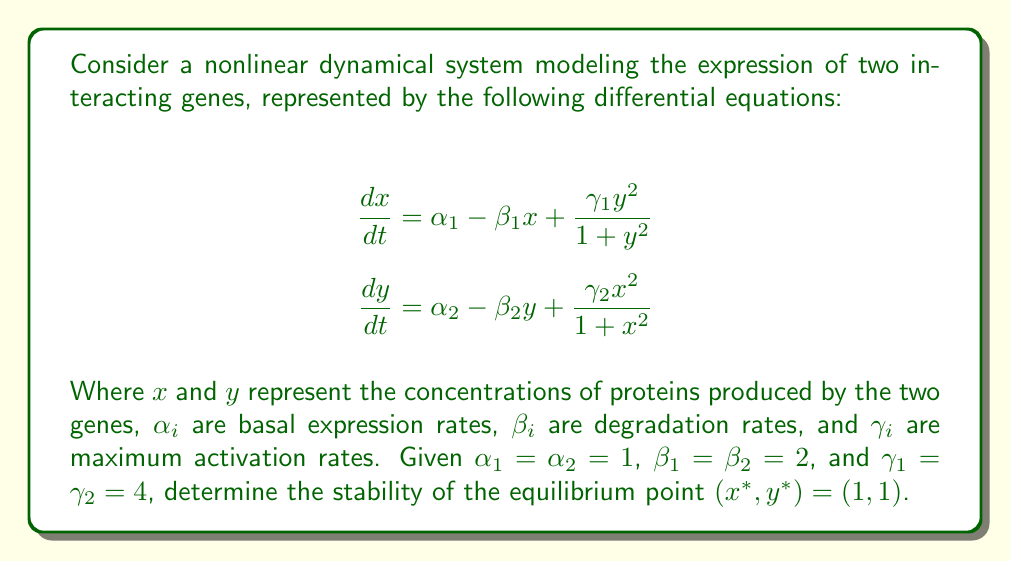What is the answer to this math problem? To analyze the stability of the equilibrium point, we need to follow these steps:

1) Calculate the Jacobian matrix of the system at the equilibrium point.
2) Find the eigenvalues of the Jacobian matrix.
3) Determine the stability based on the signs of the real parts of the eigenvalues.

Step 1: Calculate the Jacobian matrix

The Jacobian matrix is given by:

$$J = \begin{bmatrix}
\frac{\partial f_1}{\partial x} & \frac{\partial f_1}{\partial y} \\
\frac{\partial f_2}{\partial x} & \frac{\partial f_2}{\partial y}
\end{bmatrix}$$

Where:
$$\begin{align}
f_1 &= \alpha_1 - \beta_1 x + \frac{\gamma_1 y^2}{1 + y^2} \\
f_2 &= \alpha_2 - \beta_2 y + \frac{\gamma_2 x^2}{1 + x^2}
\end{align}$$

Calculating the partial derivatives:

$$\begin{align}
\frac{\partial f_1}{\partial x} &= -\beta_1 = -2 \\
\frac{\partial f_1}{\partial y} &= \frac{2\gamma_1 y}{(1 + y^2)^2} = \frac{8}{4} = 2 \quad \text{(at } y = 1\text{)} \\
\frac{\partial f_2}{\partial x} &= \frac{2\gamma_2 x}{(1 + x^2)^2} = \frac{8}{4} = 2 \quad \text{(at } x = 1\text{)} \\
\frac{\partial f_2}{\partial y} &= -\beta_2 = -2
\end{align}$$

Therefore, the Jacobian matrix at $(1, 1)$ is:

$$J = \begin{bmatrix}
-2 & 2 \\
2 & -2
\end{bmatrix}$$

Step 2: Find the eigenvalues

The characteristic equation is:
$$\det(J - \lambda I) = \begin{vmatrix}
-2 - \lambda & 2 \\
2 & -2 - \lambda
\end{vmatrix} = \lambda^2 + 4\lambda = 0$$

Solving this equation:
$$\lambda(\lambda + 4) = 0$$
$$\lambda_1 = 0, \lambda_2 = -4$$

Step 3: Determine stability

The eigenvalues are $\lambda_1 = 0$ and $\lambda_2 = -4$. Since one eigenvalue is zero and the other is negative, this equilibrium point is non-hyperbolic. We cannot determine the stability using linear stability analysis alone.

To fully determine the stability, we would need to use center manifold theory or other nonlinear analysis techniques. However, the presence of a zero eigenvalue suggests that the system might exhibit structural instability or bifurcations near this equilibrium point.
Answer: Non-hyperbolic equilibrium point; stability cannot be determined by linear analysis alone. 